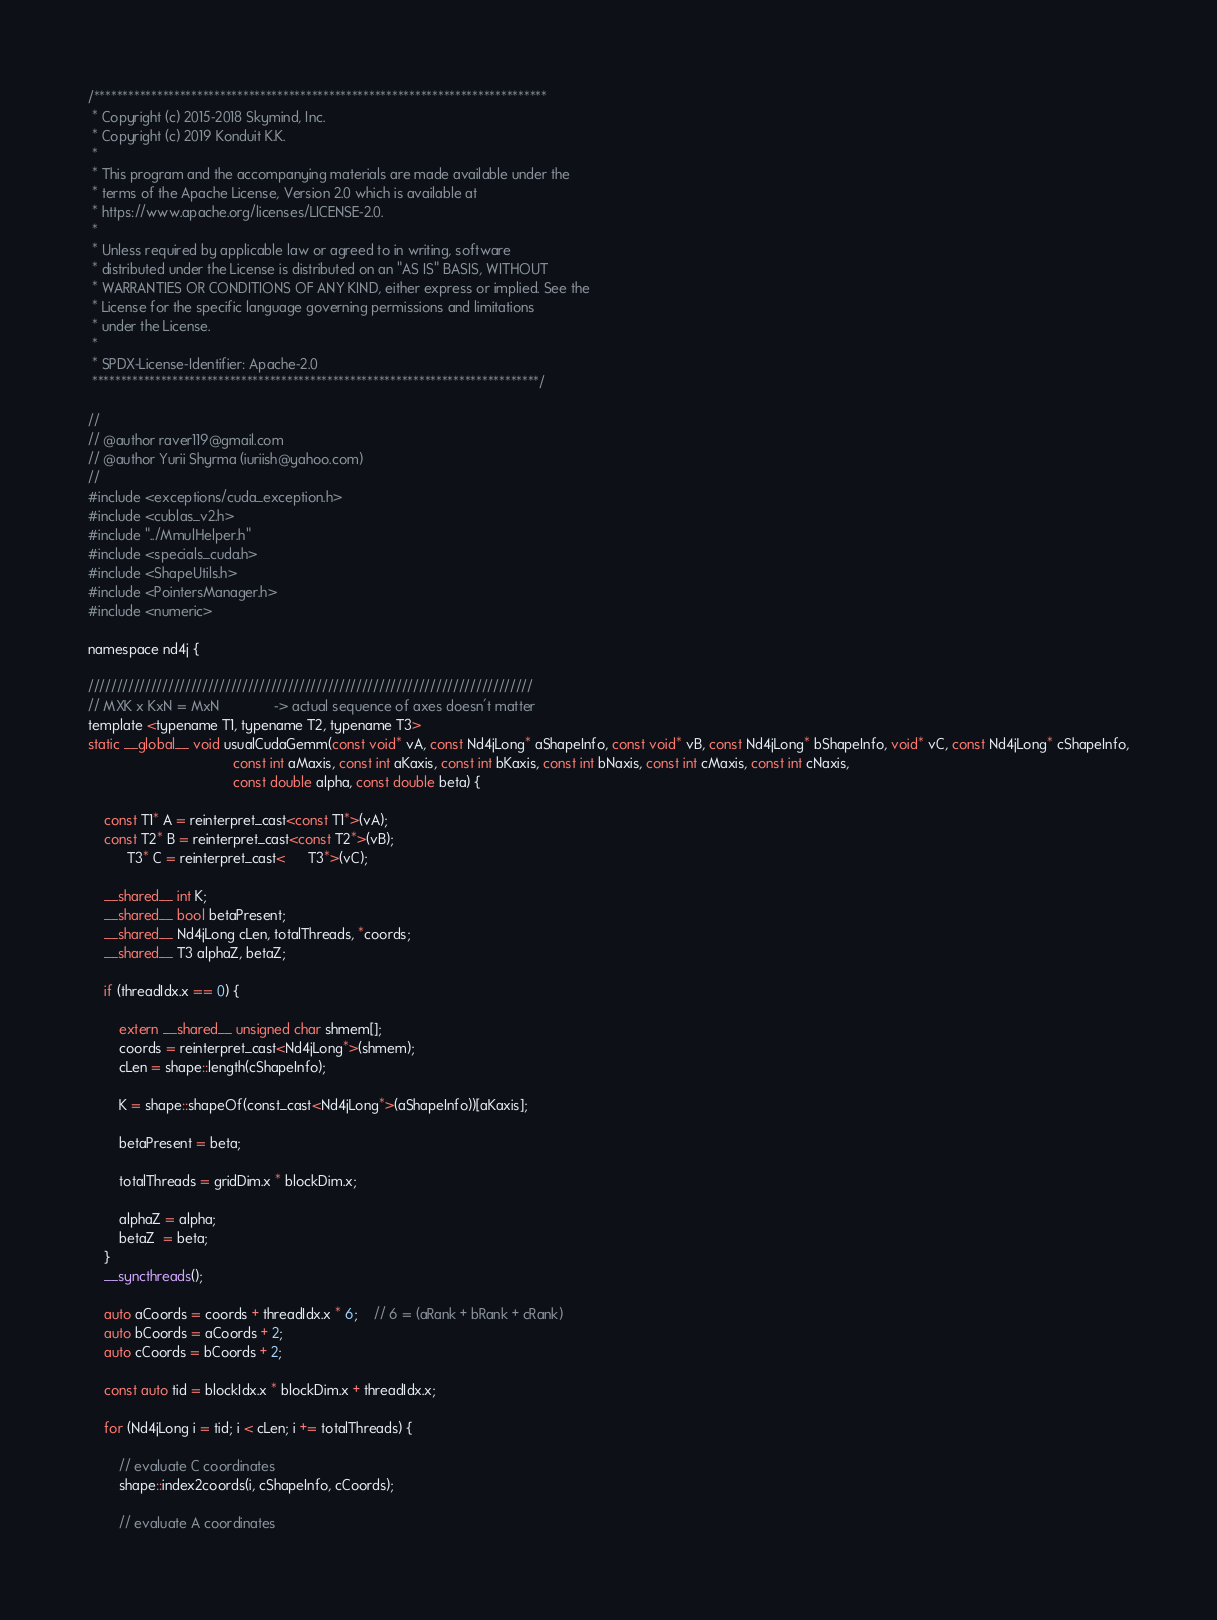Convert code to text. <code><loc_0><loc_0><loc_500><loc_500><_Cuda_>/*******************************************************************************
 * Copyright (c) 2015-2018 Skymind, Inc.
 * Copyright (c) 2019 Konduit K.K.
 *
 * This program and the accompanying materials are made available under the
 * terms of the Apache License, Version 2.0 which is available at
 * https://www.apache.org/licenses/LICENSE-2.0.
 *
 * Unless required by applicable law or agreed to in writing, software
 * distributed under the License is distributed on an "AS IS" BASIS, WITHOUT
 * WARRANTIES OR CONDITIONS OF ANY KIND, either express or implied. See the
 * License for the specific language governing permissions and limitations
 * under the License.
 *
 * SPDX-License-Identifier: Apache-2.0
 ******************************************************************************/

//
// @author raver119@gmail.com
// @author Yurii Shyrma (iuriish@yahoo.com)
//
#include <exceptions/cuda_exception.h>
#include <cublas_v2.h>
#include "../MmulHelper.h"
#include <specials_cuda.h>
#include <ShapeUtils.h>
#include <PointersManager.h>
#include <numeric>

namespace nd4j {

//////////////////////////////////////////////////////////////////////////////
// MXK x KxN = MxN              -> actual sequence of axes doesn't matter
template <typename T1, typename T2, typename T3>
static __global__ void usualCudaGemm(const void* vA, const Nd4jLong* aShapeInfo, const void* vB, const Nd4jLong* bShapeInfo, void* vC, const Nd4jLong* cShapeInfo,
                                     const int aMaxis, const int aKaxis, const int bKaxis, const int bNaxis, const int cMaxis, const int cNaxis,
                                     const double alpha, const double beta) {

    const T1* A = reinterpret_cast<const T1*>(vA);
    const T2* B = reinterpret_cast<const T2*>(vB);
          T3* C = reinterpret_cast<      T3*>(vC);

    __shared__ int K;
    __shared__ bool betaPresent;
    __shared__ Nd4jLong cLen, totalThreads, *coords;
    __shared__ T3 alphaZ, betaZ;

    if (threadIdx.x == 0) {

        extern __shared__ unsigned char shmem[];
        coords = reinterpret_cast<Nd4jLong*>(shmem);
        cLen = shape::length(cShapeInfo);

        K = shape::shapeOf(const_cast<Nd4jLong*>(aShapeInfo))[aKaxis];

        betaPresent = beta;

        totalThreads = gridDim.x * blockDim.x;

        alphaZ = alpha;
        betaZ  = beta;
    }
    __syncthreads();

    auto aCoords = coords + threadIdx.x * 6;    // 6 = (aRank + bRank + cRank)
    auto bCoords = aCoords + 2;
    auto cCoords = bCoords + 2;

    const auto tid = blockIdx.x * blockDim.x + threadIdx.x;

    for (Nd4jLong i = tid; i < cLen; i += totalThreads) {

        // evaluate C coordinates
        shape::index2coords(i, cShapeInfo, cCoords);

        // evaluate A coordinates</code> 